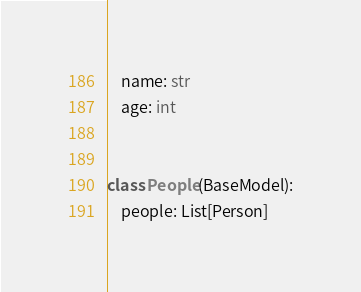<code> <loc_0><loc_0><loc_500><loc_500><_Python_>    name: str
    age: int


class People(BaseModel):
    people: List[Person]
</code> 